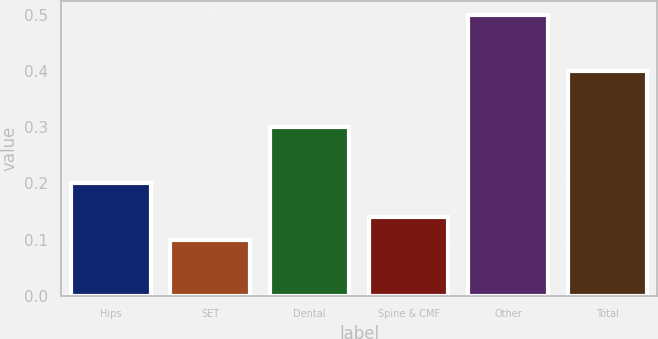<chart> <loc_0><loc_0><loc_500><loc_500><bar_chart><fcel>Hips<fcel>SET<fcel>Dental<fcel>Spine & CMF<fcel>Other<fcel>Total<nl><fcel>0.2<fcel>0.1<fcel>0.3<fcel>0.14<fcel>0.5<fcel>0.4<nl></chart> 